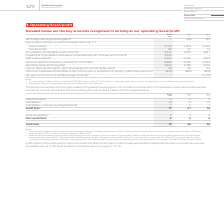From Vodafone Group Plc's financial document, Which financial years' information is shown in the table? The document contains multiple relevant values: 2017, 2018, 2019. From the document: "2019 2018 2017 €m €m €m Net foreign exchange losses/(gains) 1 1 (65) 133 Depreciation of property, plant and equip 2019 2018 2017 €m €m €m Net foreign..." Also, What information does the table show? The total remuneration of the Group’s auditors, PricewaterhouseCoopers LLP and other member firms of PricewaterhouseCoopers International Limited, for services provided to the Group during the year ended 31 March 2019. The document states: "The total remuneration of the Group’s auditors, PricewaterhouseCoopers LLP and other member firms of PricewaterhouseCoopers International Limited, for..." Also, How much is the 2019 audit fees ? According to the financial document, 17 (in millions). The relevant text states: "2019 2018 2017 €m €m €m Net foreign exchange losses/(gains) 1 1 (65) 133 Depreciation of property, plant and equipm..." Also, can you calculate: What is the average audit fees for 2018 and 2019? To answer this question, I need to perform calculations using the financial data. The calculation is: (17+21)/2, which equals 19 (in millions). This is based on the information: "– new accounting standards 1 1 5 1 Audit fees: 17 21 16 es – new accounting standards 1 1 5 1 Audit fees: 17 21 16..." The key data points involved are: 17, 21. Also, can you calculate: What is the average total fees for 2018 and 2019? To answer this question, I need to perform calculations using the financial data. The calculation is: (19+26)/2, which equals 22.5 (in millions). This is based on the information: "Total fees 19 26 20 Total fees 19 26 20..." The key data points involved are: 19, 26. Also, can you calculate: What is the difference between the average audit fees and the average total fees for 2018 and 2019? To answer this question, I need to perform calculations using the financial data. The calculation is: [(17+21)/2] - [(19+26)/2], which equals -3.5 (in millions). This is based on the information: "Total fees 19 26 20 2019 2018 2017 €m €m €m Net foreign exchange losses/(gains) 1 1 (65) 133 Depreciation of property, plant 2019 2018 2017 €m €m €m Net foreign exchange losses/(gains) 1 1 (65) 133 De..." The key data points involved are: 17, 19, 2. 